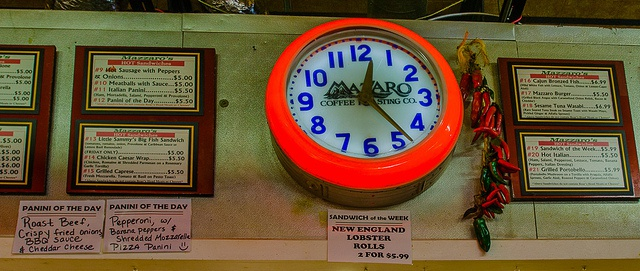Describe the objects in this image and their specific colors. I can see a clock in black, red, darkgray, and teal tones in this image. 